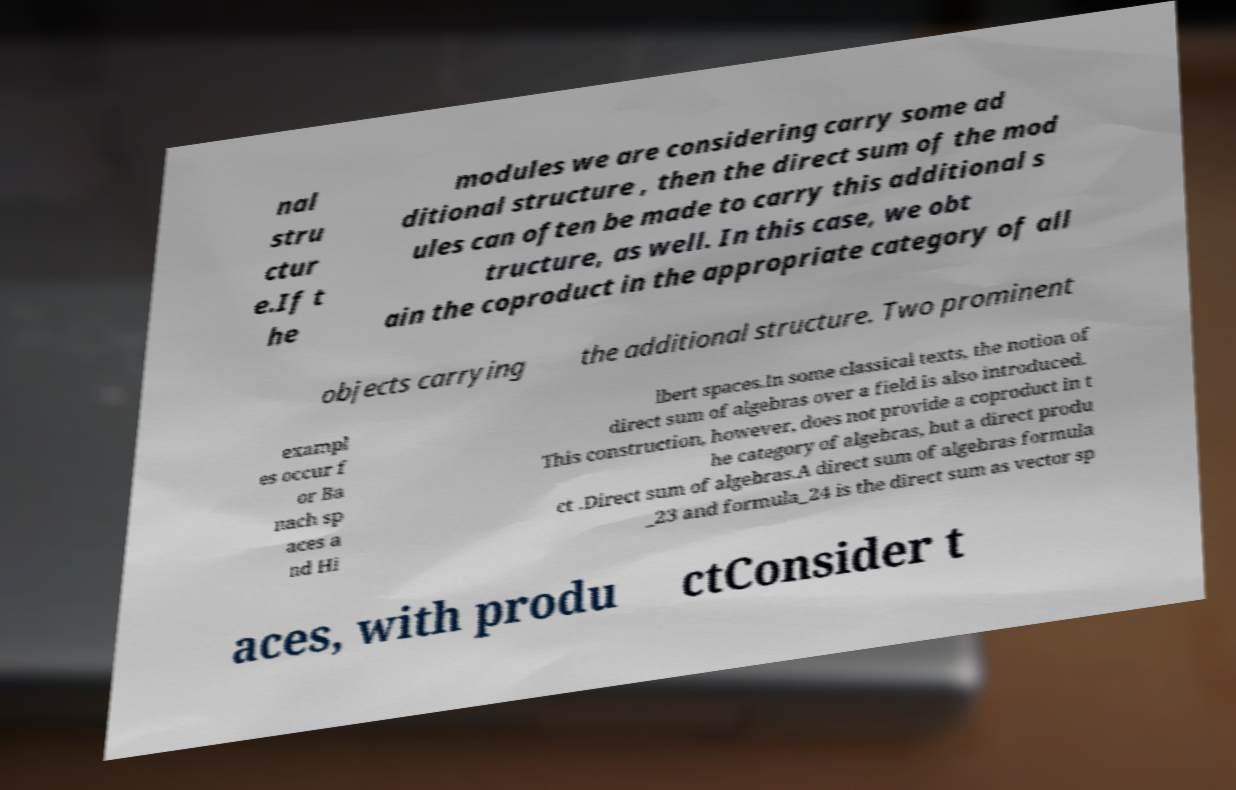I need the written content from this picture converted into text. Can you do that? nal stru ctur e.If t he modules we are considering carry some ad ditional structure , then the direct sum of the mod ules can often be made to carry this additional s tructure, as well. In this case, we obt ain the coproduct in the appropriate category of all objects carrying the additional structure. Two prominent exampl es occur f or Ba nach sp aces a nd Hi lbert spaces.In some classical texts, the notion of direct sum of algebras over a field is also introduced. This construction, however, does not provide a coproduct in t he category of algebras, but a direct produ ct .Direct sum of algebras.A direct sum of algebras formula _23 and formula_24 is the direct sum as vector sp aces, with produ ctConsider t 